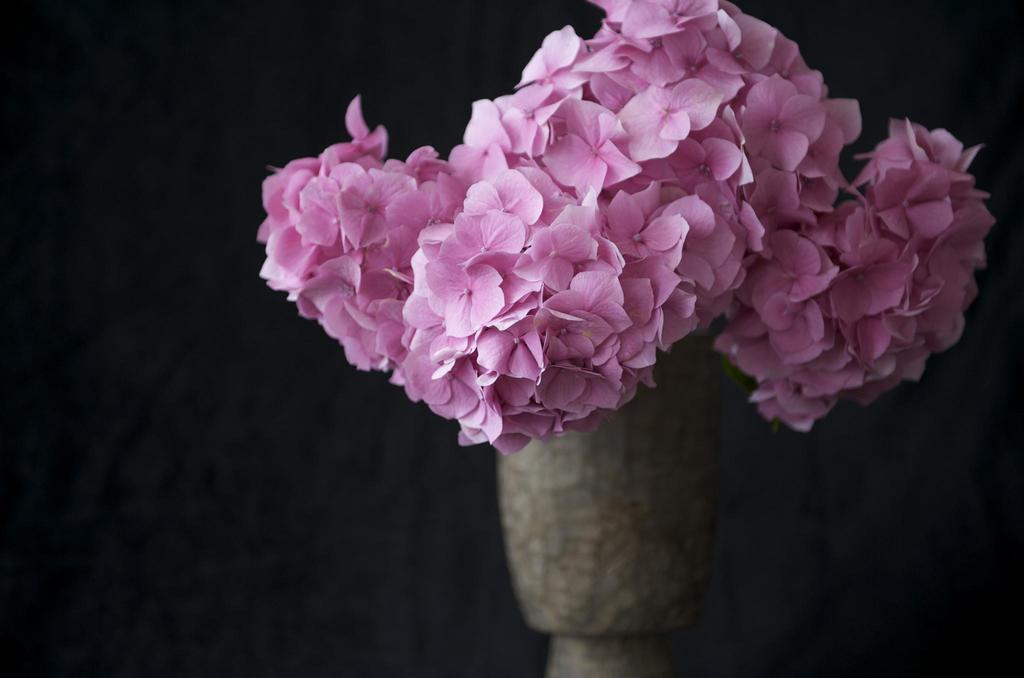What type of flowers are in the foreground of the image? There are pink flowers in the foreground of the image. How is the background of the flowers depicted in the image? The background of the flowers is blurred. What mathematical operation is being performed on the flowers in the image? There is no mathematical operation being performed on the flowers in the image. 